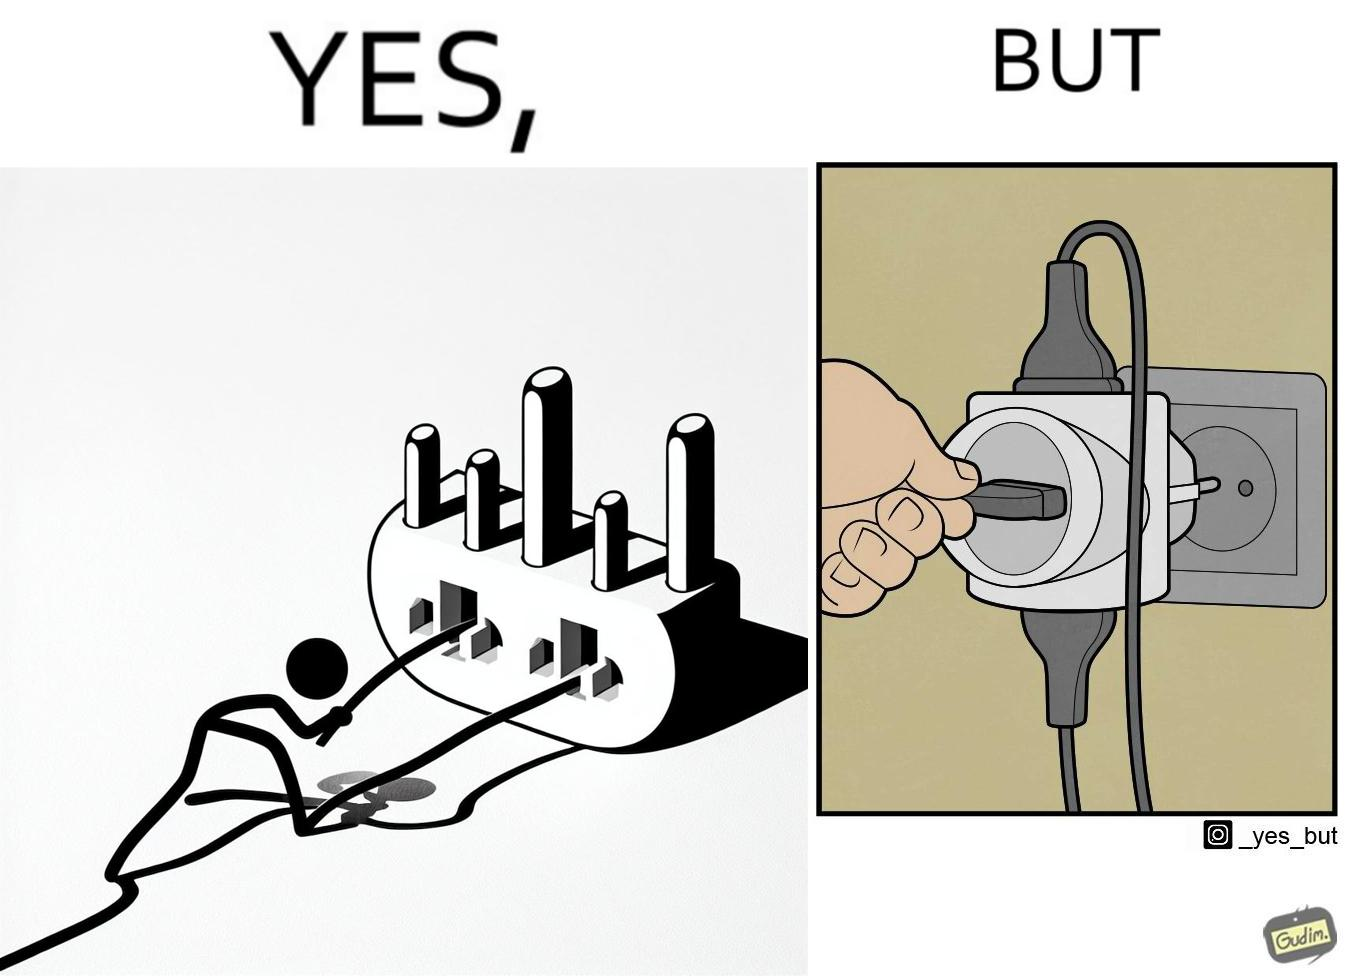What is shown in this image? The image is ironic, because some person is trying to plug out one pin from the multi pin plug but due to tight fitting the multi pin plug socket itself is getting pulled off disconnecting the power supply to other devices even when it is not required 